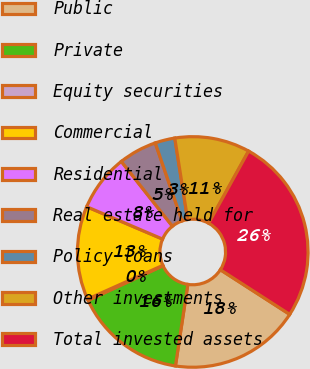Convert chart. <chart><loc_0><loc_0><loc_500><loc_500><pie_chart><fcel>Public<fcel>Private<fcel>Equity securities<fcel>Commercial<fcel>Residential<fcel>Real estate held for<fcel>Policy loans<fcel>Other investments<fcel>Total invested assets<nl><fcel>18.3%<fcel>15.71%<fcel>0.19%<fcel>13.12%<fcel>7.95%<fcel>5.36%<fcel>2.78%<fcel>10.54%<fcel>26.06%<nl></chart> 